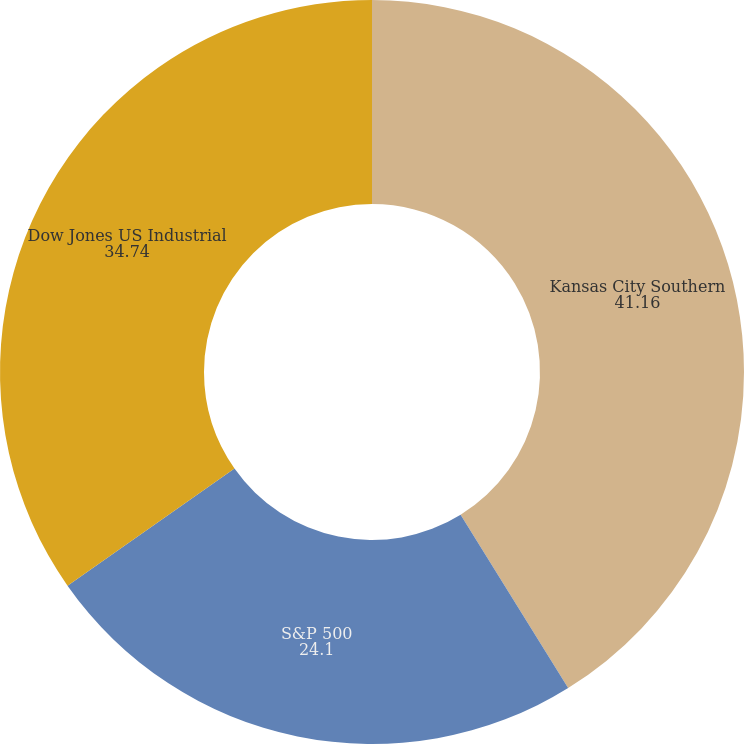<chart> <loc_0><loc_0><loc_500><loc_500><pie_chart><fcel>Kansas City Southern<fcel>S&P 500<fcel>Dow Jones US Industrial<nl><fcel>41.16%<fcel>24.1%<fcel>34.74%<nl></chart> 